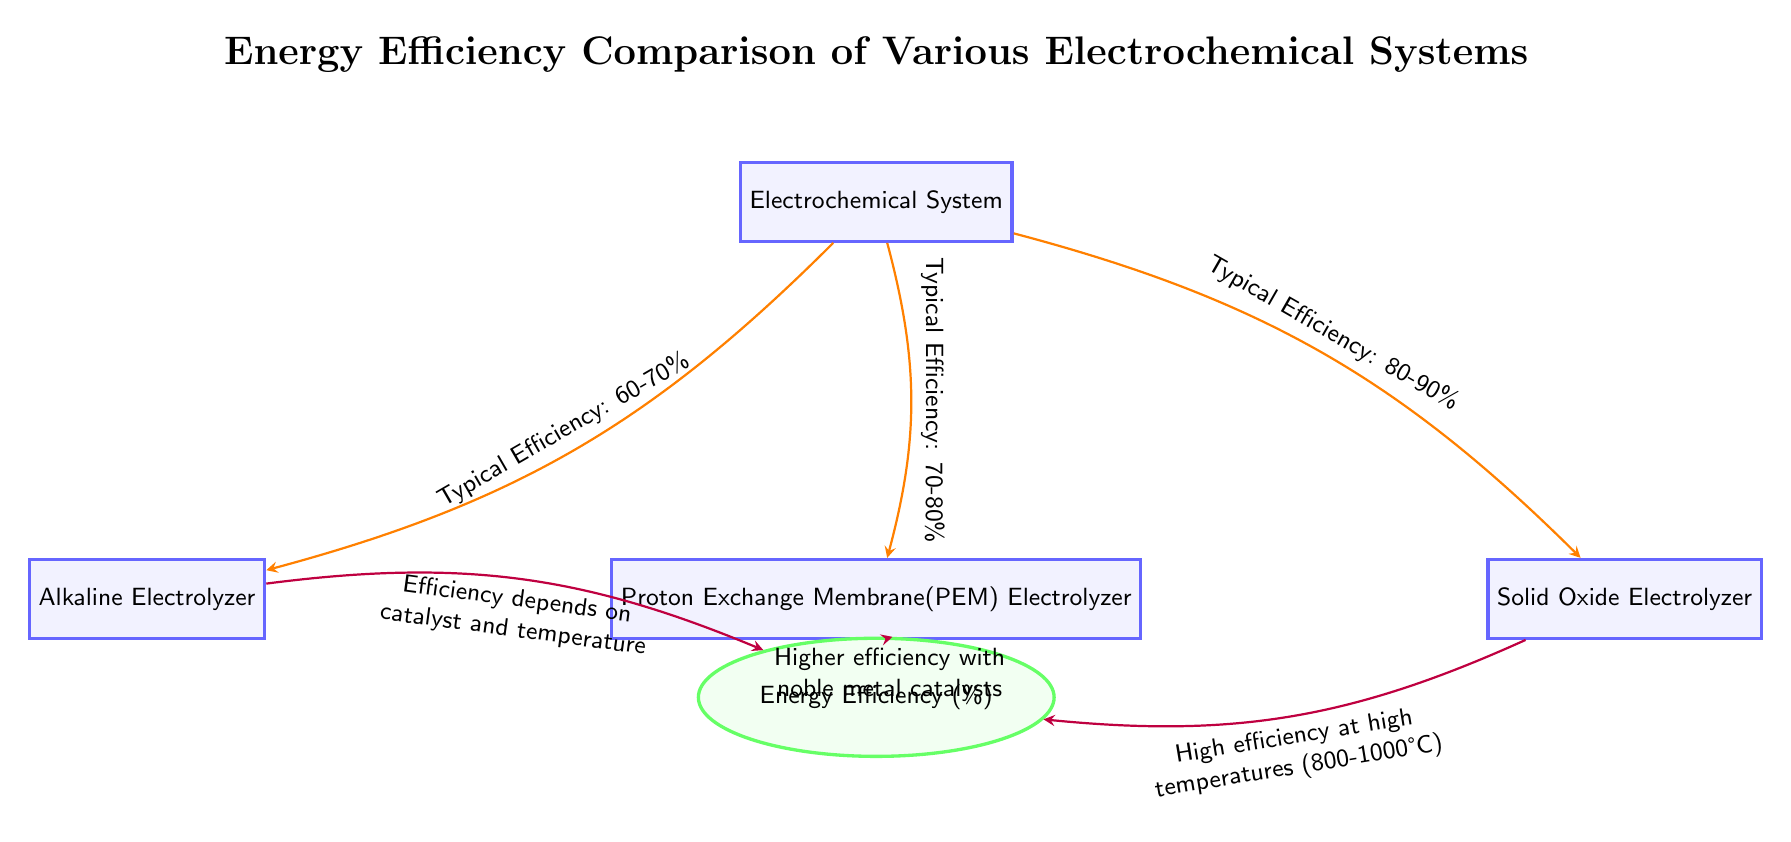What is the typical efficiency range of the Alkaline Electrolyzer? The diagram states that the Alkaline Electrolyzer has a typical efficiency range of 60-70%, as indicated by the arrow connecting "Electrochemical System" to "Alkaline Electrolyzer."
Answer: 60-70% What is the efficiency of the Proton Exchange Membrane Electrolyzer? According to the diagram, the Proton Exchange Membrane (PEM) Electrolyzer has a typical efficiency range of 70-80%, cited on the arrow directed towards it from the central Electrochemical System node.
Answer: 70-80% Which electrochemical system has the highest typical efficiency? The Solid Oxide Electrolyzer has the highest typical efficiency shown in the diagram, which is indicated to be in the range of 80-90% on the arrow flowing from the Electrochemical System node.
Answer: 80-90% What factors influence the efficiency of the Alkaline Electrolyzer? The diagram mentions that the efficiency of the Alkaline Electrolyzer depends on the catalyst and temperature, as stated on the arrow leading from Alkaline Electrolyzer to the efficiency node.
Answer: Catalyst and temperature How does the efficiency of the Proton Exchange Membrane Electrolyzer improve? The diagram indicates that the efficiency of the Proton Exchange Membrane Electrolyzer increases with the use of noble metal catalysts, as noted on the connecting arrow to the energy efficiency node.
Answer: Noble metal catalysts At what temperature does the Solid Oxide Electrolyzer achieve high efficiency? The diagram specifies that the Solid Oxide Electrolyzer achieves high efficiency at high temperatures, particularly between 800-1000°C, as indicated on the arrow pointing from it to the efficiency node.
Answer: 800-1000°C What is the total number of electrochemical systems presented in the diagram? The diagram illustrates a total of three electrochemical systems: Alkaline Electrolyzer, Proton Exchange Membrane Electrolyzer, and Solid Oxide Electrolyzer, all connected to the central Electrochemical System node.
Answer: Three What is the relationship between the Electrochemical System and the efficiency node? The relationship is that the three electrochemical systems are evaluated based on their typical efficiencies, which stem from their connections to the central Electrochemical System node.
Answer: Evaluation of efficiencies 